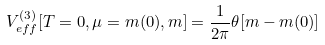Convert formula to latex. <formula><loc_0><loc_0><loc_500><loc_500>V _ { e f f } ^ { ( 3 ) } [ T = 0 , \mu = m ( 0 ) , m ] = \frac { 1 } { 2 \pi } \theta [ m - m ( 0 ) ]</formula> 